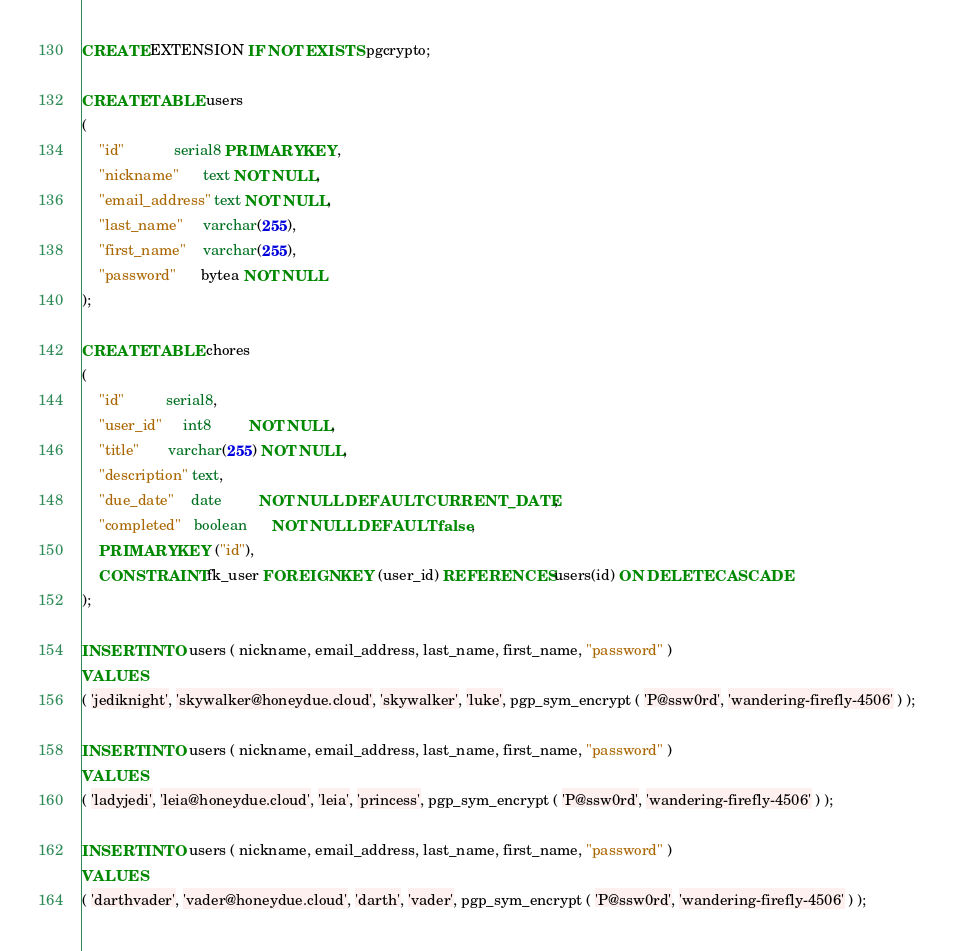Convert code to text. <code><loc_0><loc_0><loc_500><loc_500><_SQL_>CREATE EXTENSION IF NOT EXISTS pgcrypto;

CREATE TABLE users
(
    "id"            serial8 PRIMARY KEY,
    "nickname"      text NOT NULL,
    "email_address" text NOT NULL,
    "last_name"     varchar(255),
    "first_name"    varchar(255),
    "password"      bytea NOT NULL
);

CREATE TABLE chores
(
    "id"          serial8,
    "user_id"     int8         NOT NULL,
    "title"       varchar(255) NOT NULL,
    "description" text,
    "due_date"    date         NOT NULL DEFAULT CURRENT_DATE,
    "completed"   boolean      NOT NULL DEFAULT false,
    PRIMARY KEY ("id"),
    CONSTRAINT fk_user FOREIGN KEY (user_id) REFERENCES users(id) ON DELETE CASCADE
);

INSERT INTO users ( nickname, email_address, last_name, first_name, "password" )
VALUES
( 'jediknight', 'skywalker@honeydue.cloud', 'skywalker', 'luke', pgp_sym_encrypt ( 'P@ssw0rd', 'wandering-firefly-4506' ) );

INSERT INTO users ( nickname, email_address, last_name, first_name, "password" )
VALUES
( 'ladyjedi', 'leia@honeydue.cloud', 'leia', 'princess', pgp_sym_encrypt ( 'P@ssw0rd', 'wandering-firefly-4506' ) );

INSERT INTO users ( nickname, email_address, last_name, first_name, "password" )
VALUES
( 'darthvader', 'vader@honeydue.cloud', 'darth', 'vader', pgp_sym_encrypt ( 'P@ssw0rd', 'wandering-firefly-4506' ) );</code> 